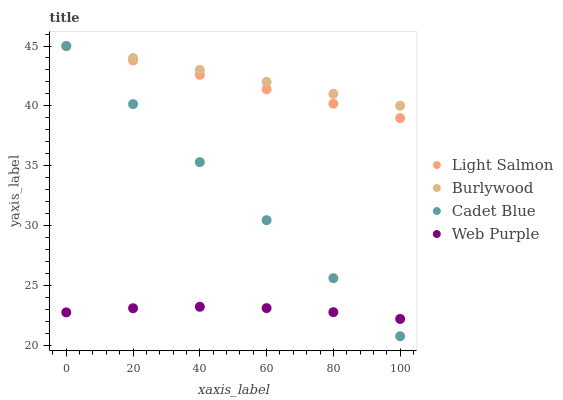Does Web Purple have the minimum area under the curve?
Answer yes or no. Yes. Does Burlywood have the maximum area under the curve?
Answer yes or no. Yes. Does Light Salmon have the minimum area under the curve?
Answer yes or no. No. Does Light Salmon have the maximum area under the curve?
Answer yes or no. No. Is Cadet Blue the smoothest?
Answer yes or no. Yes. Is Web Purple the roughest?
Answer yes or no. Yes. Is Light Salmon the smoothest?
Answer yes or no. No. Is Light Salmon the roughest?
Answer yes or no. No. Does Cadet Blue have the lowest value?
Answer yes or no. Yes. Does Light Salmon have the lowest value?
Answer yes or no. No. Does Cadet Blue have the highest value?
Answer yes or no. Yes. Does Web Purple have the highest value?
Answer yes or no. No. Is Web Purple less than Light Salmon?
Answer yes or no. Yes. Is Burlywood greater than Web Purple?
Answer yes or no. Yes. Does Light Salmon intersect Cadet Blue?
Answer yes or no. Yes. Is Light Salmon less than Cadet Blue?
Answer yes or no. No. Is Light Salmon greater than Cadet Blue?
Answer yes or no. No. Does Web Purple intersect Light Salmon?
Answer yes or no. No. 